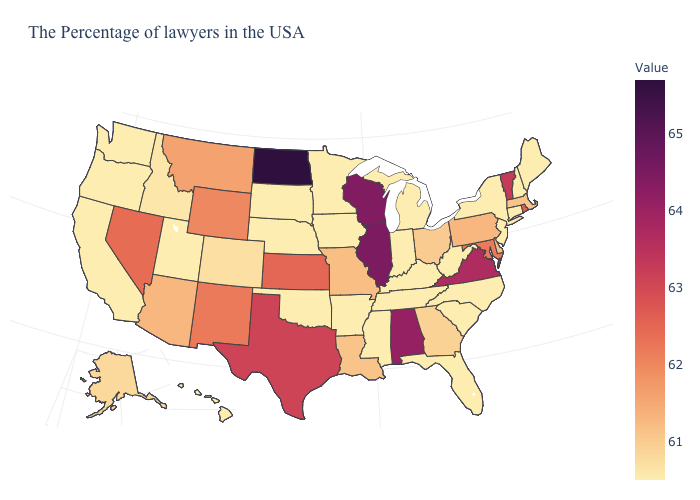Is the legend a continuous bar?
Keep it brief. Yes. Does Missouri have the lowest value in the USA?
Give a very brief answer. No. Does Texas have the highest value in the South?
Answer briefly. No. Does South Carolina have the highest value in the South?
Concise answer only. No. Does New York have the lowest value in the Northeast?
Short answer required. Yes. 